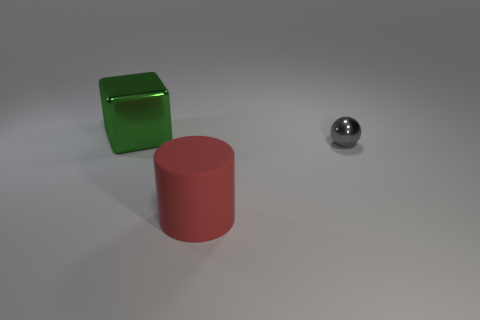There is a thing that is both behind the large red rubber object and on the left side of the tiny thing; what is its material?
Offer a terse response. Metal. There is a shiny object that is right of the metallic cube; does it have the same size as the rubber thing?
Offer a very short reply. No. Does the small ball have the same color as the matte cylinder?
Offer a terse response. No. What number of things are behind the red rubber cylinder and left of the gray thing?
Your response must be concise. 1. What number of large green things are to the right of the thing in front of the metallic object right of the big green metal object?
Provide a short and direct response. 0. What is the shape of the tiny gray object?
Your answer should be compact. Sphere. How many other big things are made of the same material as the big green object?
Give a very brief answer. 0. What color is the large cube that is the same material as the sphere?
Offer a terse response. Green. There is a metal block; is it the same size as the thing in front of the tiny thing?
Your answer should be very brief. Yes. What is the material of the large object behind the large thing in front of the large object behind the cylinder?
Make the answer very short. Metal. 